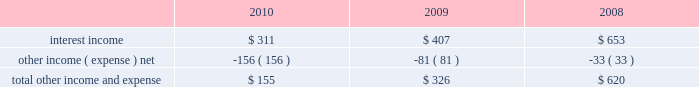Table of contents research and development expense ( 201cr&d 201d ) r&d expense increased 34% ( 34 % ) or $ 449 million to $ 1.8 billion in 2010 compared to 2009 .
This increase was due primarily to an increase in headcount and related expenses in the current year to support expanded r&d activities .
Also contributing to this increase in r&d expense in 2010 was the capitalization in 2009 of software development costs of $ 71 million related to mac os x snow leopard .
Although total r&d expense increased 34% ( 34 % ) during 2010 , it declined as a percentage of net sales given the 52% ( 52 % ) year-over-year increase in net sales in 2010 .
The company continues to believe that focused investments in r&d are critical to its future growth and competitive position in the marketplace and are directly related to timely development of new and enhanced products that are central to the company 2019s core business strategy .
As such , the company expects to make further investments in r&d to remain competitive .
R&d expense increased 20% ( 20 % ) or $ 224 million to $ 1.3 billion in 2009 compared to 2008 .
This increase was due primarily to an increase in headcount in 2009 to support expanded r&d activities and higher stock-based compensation expenses .
Additionally , $ 71 million of software development costs were capitalized related to mac os x snow leopard and excluded from r&d expense during 2009 , compared to $ 11 million of software development costs capitalized during 2008 .
Although total r&d expense increased 20% ( 20 % ) during 2009 , it remained relatively flat as a percentage of net sales given the 14% ( 14 % ) increase in revenue in 2009 .
Selling , general and administrative expense ( 201csg&a 201d ) sg&a expense increased $ 1.4 billion or 33% ( 33 % ) to $ 5.5 billion in 2010 compared to 2009 .
This increase was due primarily to the company 2019s continued expansion of its retail segment , higher spending on marketing and advertising programs , increased stock-based compensation expenses and variable costs associated with the overall growth of the company 2019s net sales .
Sg&a expenses increased $ 388 million or 10% ( 10 % ) to $ 4.1 billion in 2009 compared to 2008 .
This increase was due primarily to the company 2019s continued expansion of its retail segment in both domestic and international markets , higher stock-based compensation expense and higher spending on marketing and advertising .
Other income and expense other income and expense for the three years ended september 25 , 2010 , are as follows ( in millions ) : total other income and expense decreased $ 171 million or 52% ( 52 % ) to $ 155 million during 2010 compared to $ 326 million and $ 620 million in 2009 and 2008 , respectively .
The overall decrease in other income and expense is attributable to the significant declines in interest rates on a year- over-year basis , partially offset by the company 2019s higher cash , cash equivalents and marketable securities balances .
The weighted average interest rate earned by the company on its cash , cash equivalents and marketable securities was 0.75% ( 0.75 % ) , 1.43% ( 1.43 % ) and 3.44% ( 3.44 % ) during 2010 , 2009 and 2008 , respectively .
Additionally the company incurred higher premium expenses on its foreign exchange option contracts , which further reduced the total other income and expense .
During 2010 , 2009 and 2008 , the company had no debt outstanding and accordingly did not incur any related interest expense .
Provision for income taxes the company 2019s effective tax rates were 24% ( 24 % ) , 32% ( 32 % ) and 32% ( 32 % ) for 2010 , 2009 and 2008 , respectively .
The company 2019s effective rates for these periods differ from the statutory federal income tax rate of 35% ( 35 % ) due .

For the three year period , what was the average interest income in millions? 
Computations: table_average(interest income, none)
Answer: 457.0. 